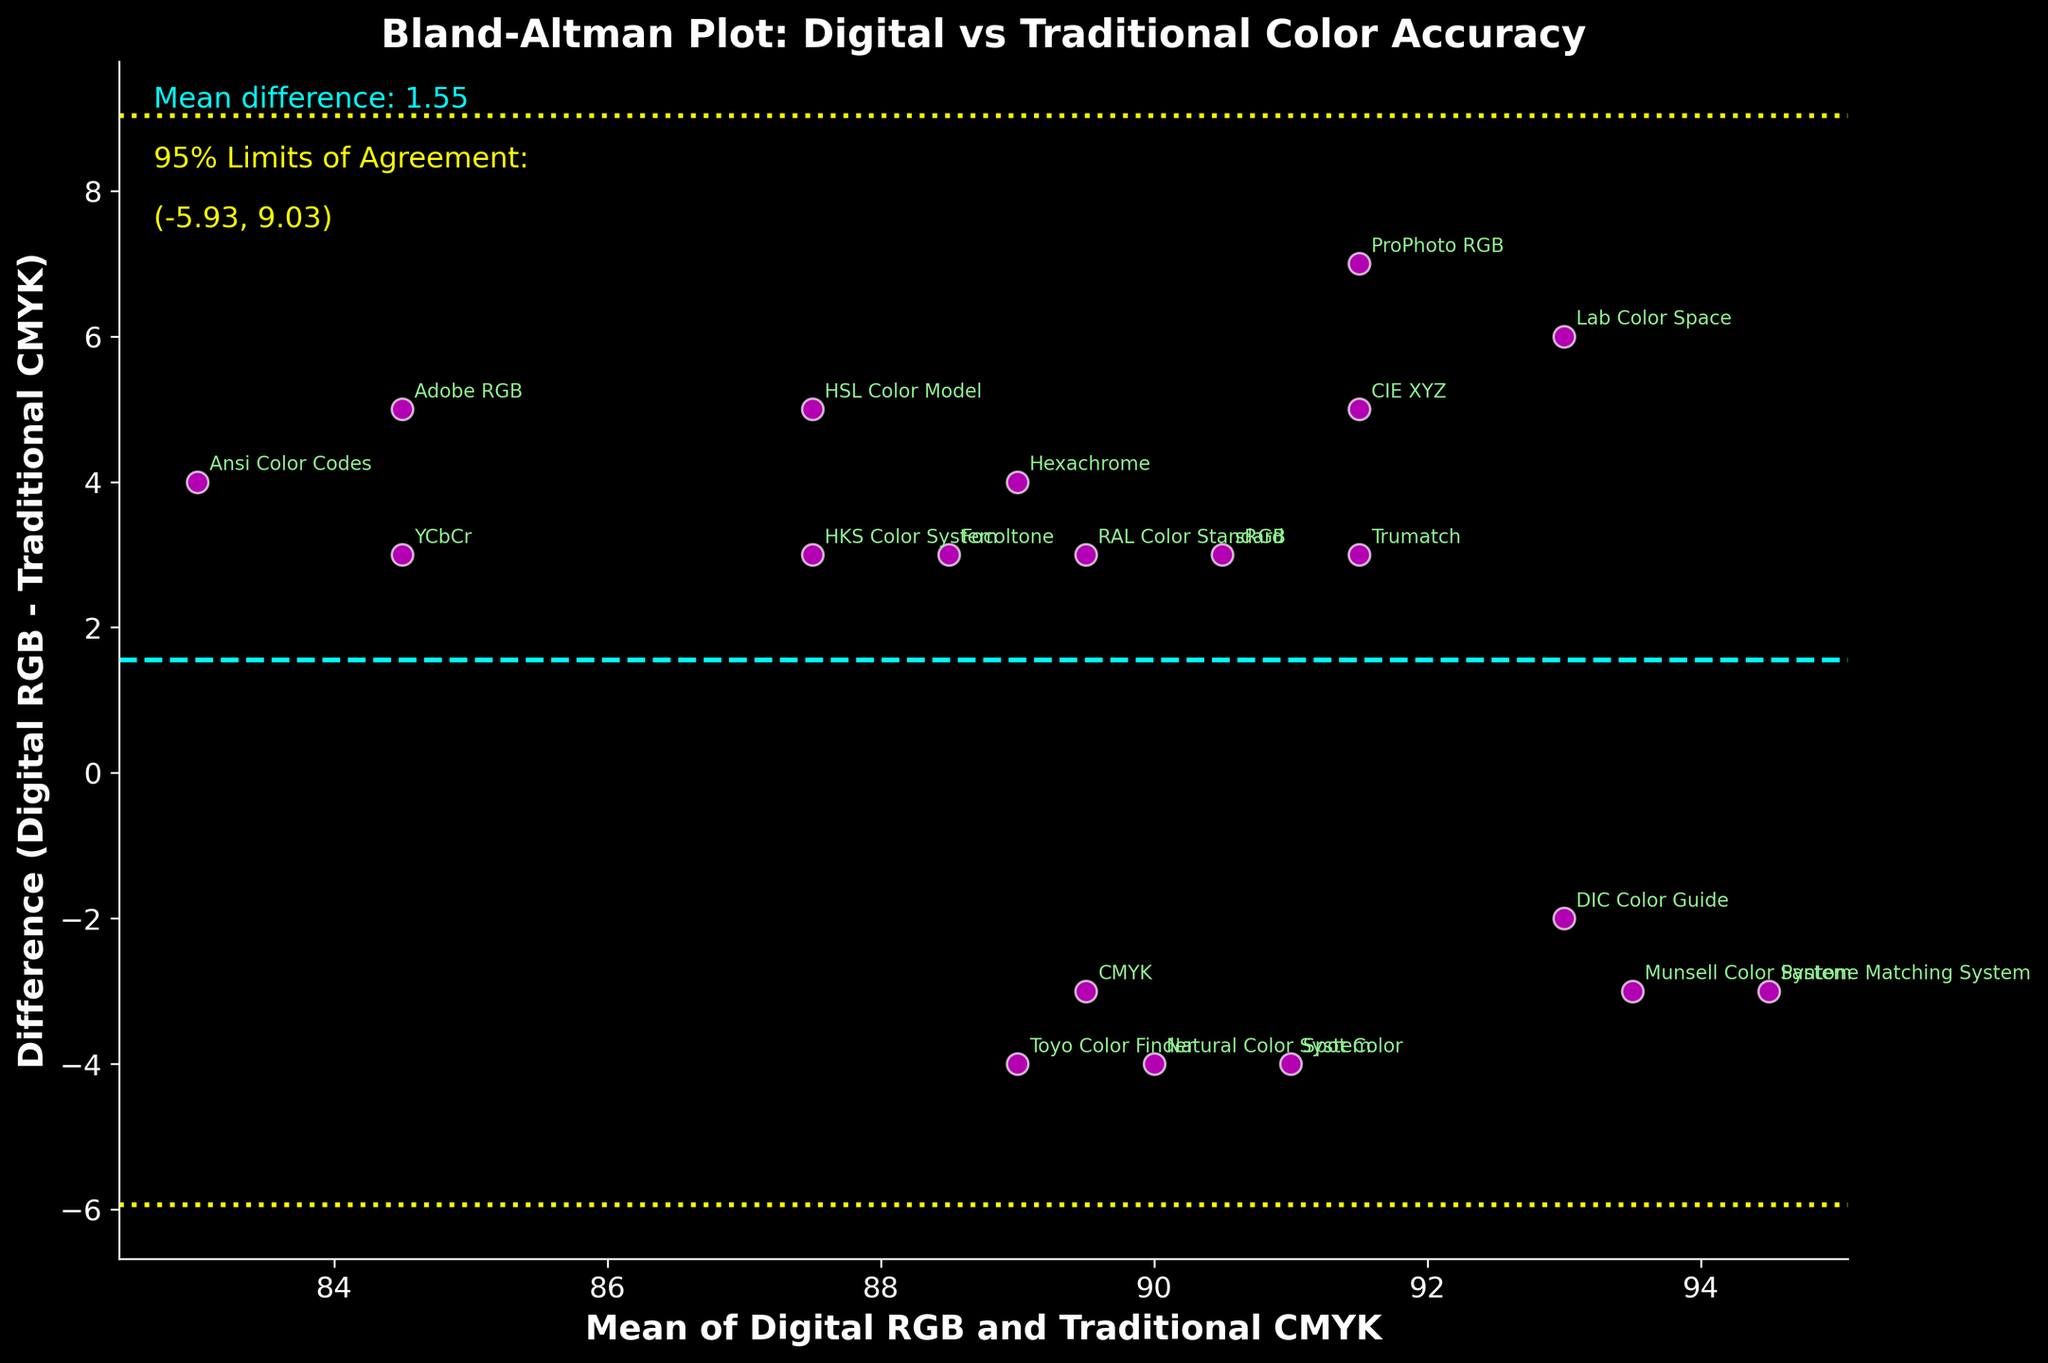What is the title of the figure? The figure's title is written as text at the top of the plot. By reading this text, the title of the figure can be identified.
Answer: Bland-Altman Plot: Digital vs Traditional Color Accuracy How many data points are represented in the plot? By counting the number of scatter points on the plot, you can determine the total number of data points represented in the figure.
Answer: 20 Which color is used to denote the scatter points? The color of the scatter points can be observed visually from the plot.
Answer: Magenta What is the mean difference between Digital RGB and Traditional CMYK? The mean difference value is provided in the plot text annotation labeled "Mean difference:".
Answer: 2.30 What value represents the lower limit of agreement? The lower limit of agreement is indicated on the plot as a yellow dashed line, and its value is provided in the annotation.
Answer: -3.00 Which method has the largest difference between Digital RGB and Traditional CMYK? By looking at the scatter points, the method with the highest absolute value on the y-axis (difference) can be identified.
Answer: ProPhoto RGB (7) What is the 95% upper limit of agreement? The upper limit of agreement is indicated on the plot as a yellow dashed line, and its value is provided in the annotation.
Answer: 7.60 By how much does the ProPhoto RGB method differ from the sRGB method in terms of color accuracy? Locate the ProPhoto RGB and sRGB methods on the y-axis, measure their differences, and calculate the absolute difference between these values. For ProPhoto RGB, the difference is 7, and for sRGB, it is 3. The difference between them is
Answer: 4 How does the color accuracy method 'Lab Color Space' compare with 'CMYK' in terms of difference value? Locate the points for 'Lab Color Space' and 'CMYK' on the y-axis, compare their difference values directly. 'Lab Color Space' has a difference of 6, while 'CMYK' has -3.
Answer: Lab Color Space is 9 units higher than CMYK 